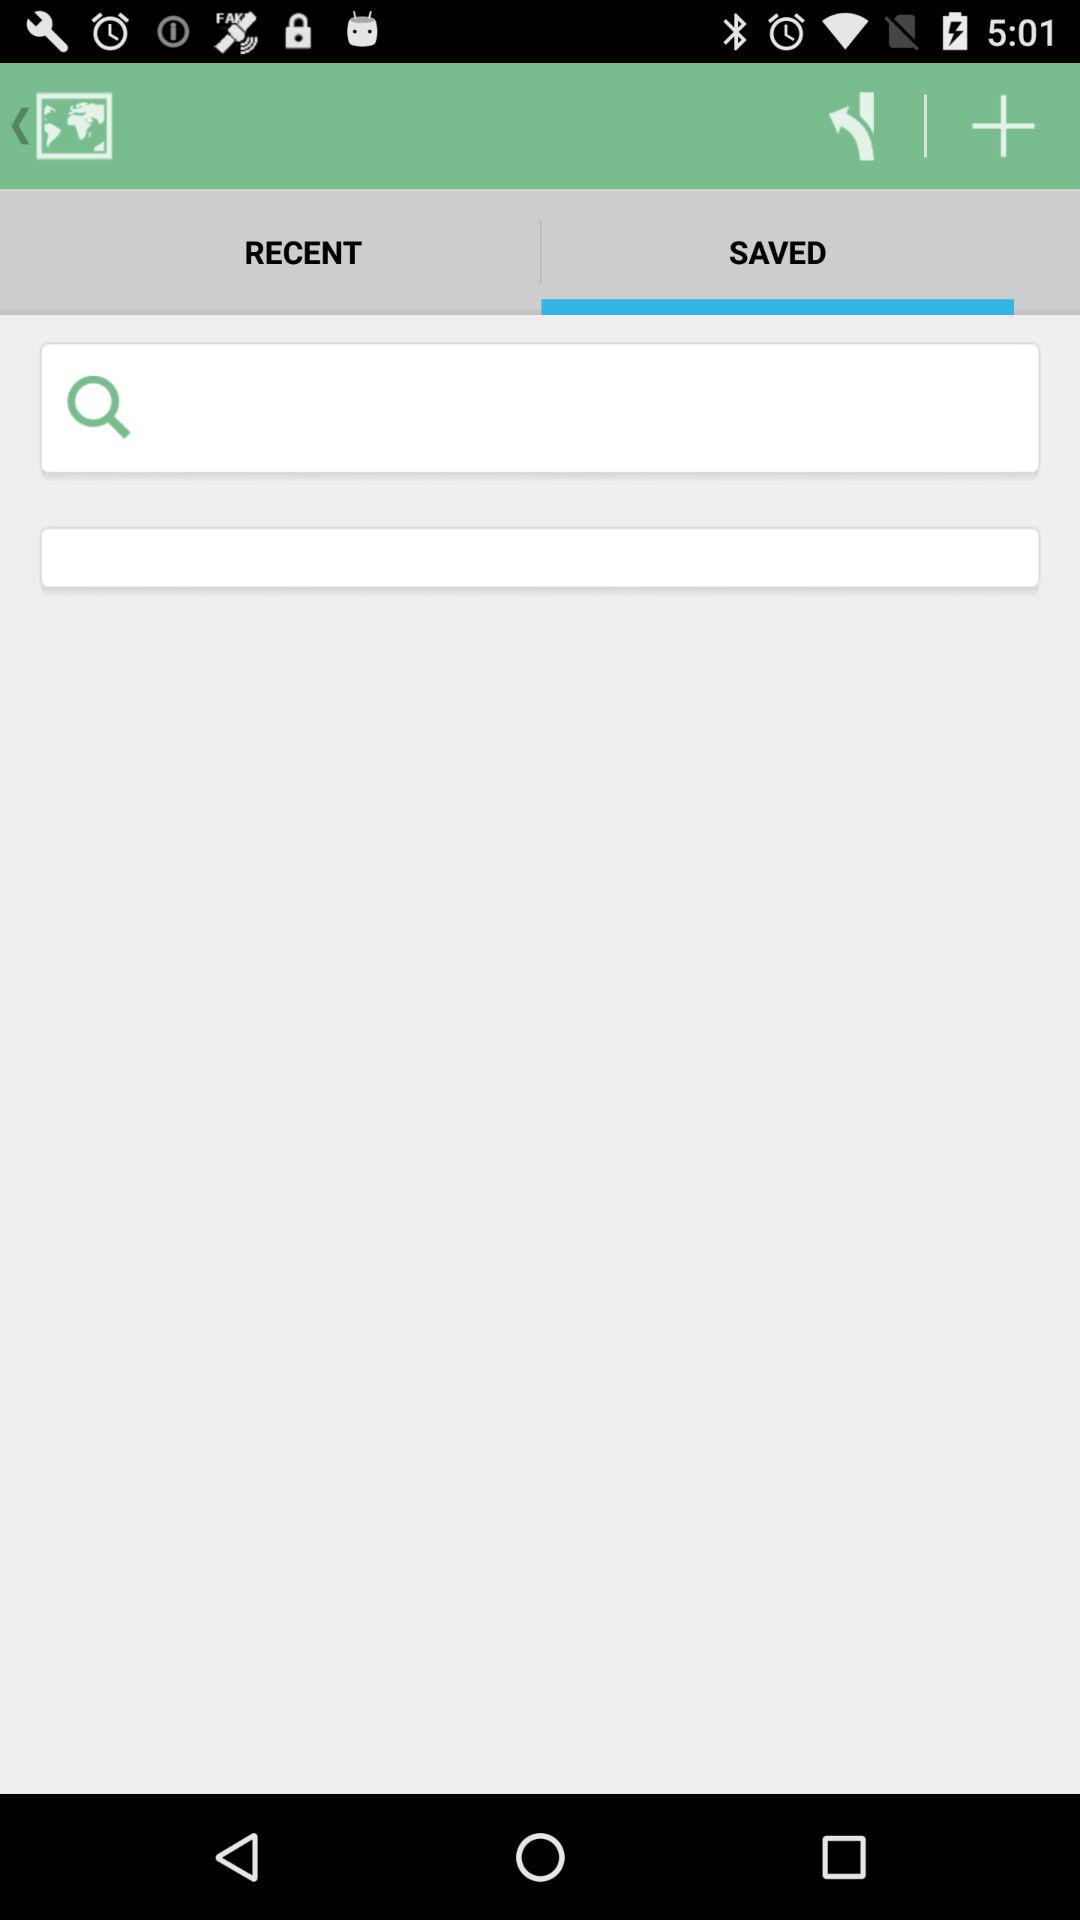Which tab has been selected? The selected tab is "SAVED". 